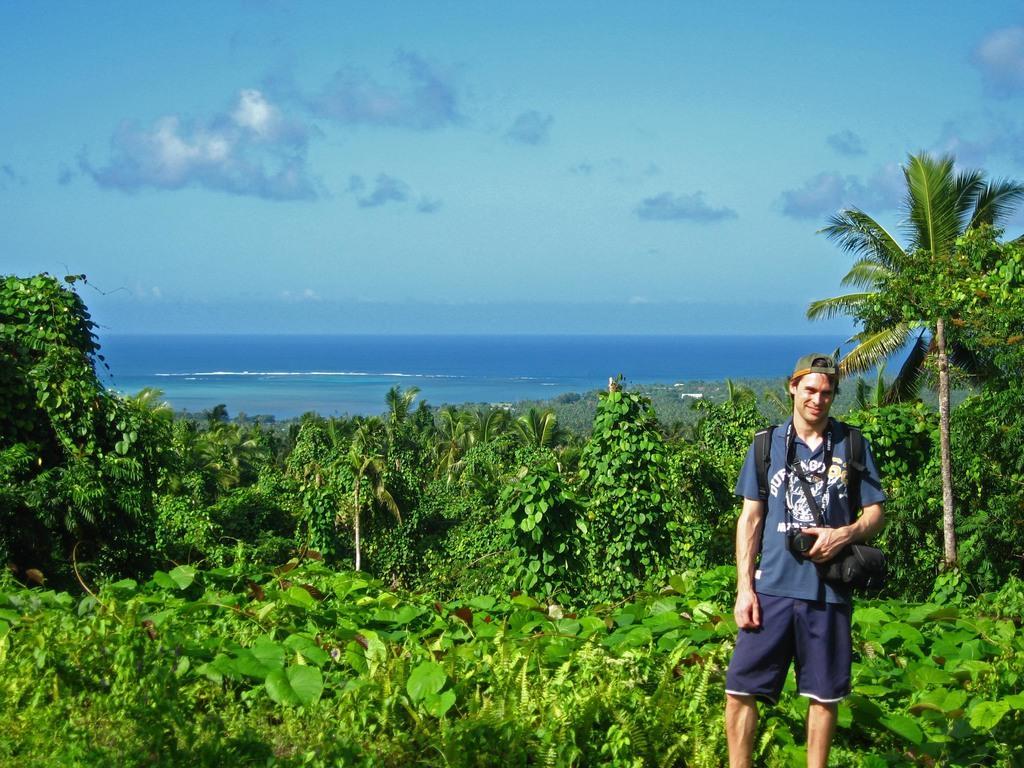What is the person in the foreground of the image doing? The person is standing in the foreground area of the image and holding a camera. What can be seen in the background of the image? In the background of the image, there are plants, trees, water, and the sky. How many different types of natural elements are visible in the background? There are four different types of natural elements visible in the background: plants, trees, water, and the sky. What is the chance of the person swimming in the water visible in the background? There is no indication in the image that the person is swimming or has any intention of swimming in the water. 